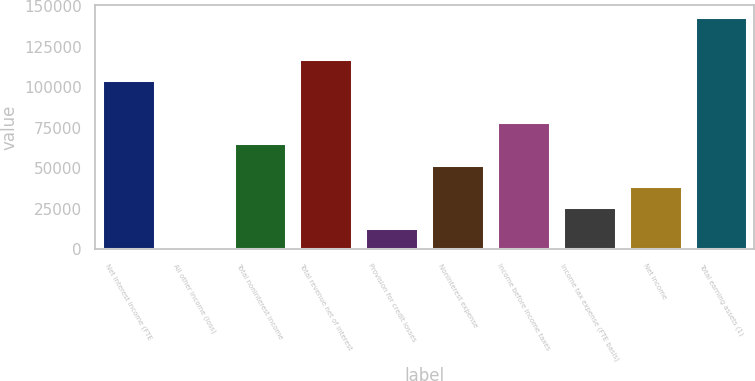<chart> <loc_0><loc_0><loc_500><loc_500><bar_chart><fcel>Net interest income (FTE<fcel>All other income (loss)<fcel>Total noninterest income<fcel>Total revenue net of interest<fcel>Provision for credit losses<fcel>Noninterest expense<fcel>Income before income taxes<fcel>Income tax expense (FTE basis)<fcel>Net income<fcel>Total earning assets (1)<nl><fcel>104269<fcel>328<fcel>65291<fcel>117261<fcel>13320.6<fcel>52298.4<fcel>78283.6<fcel>26313.2<fcel>39305.8<fcel>143247<nl></chart> 